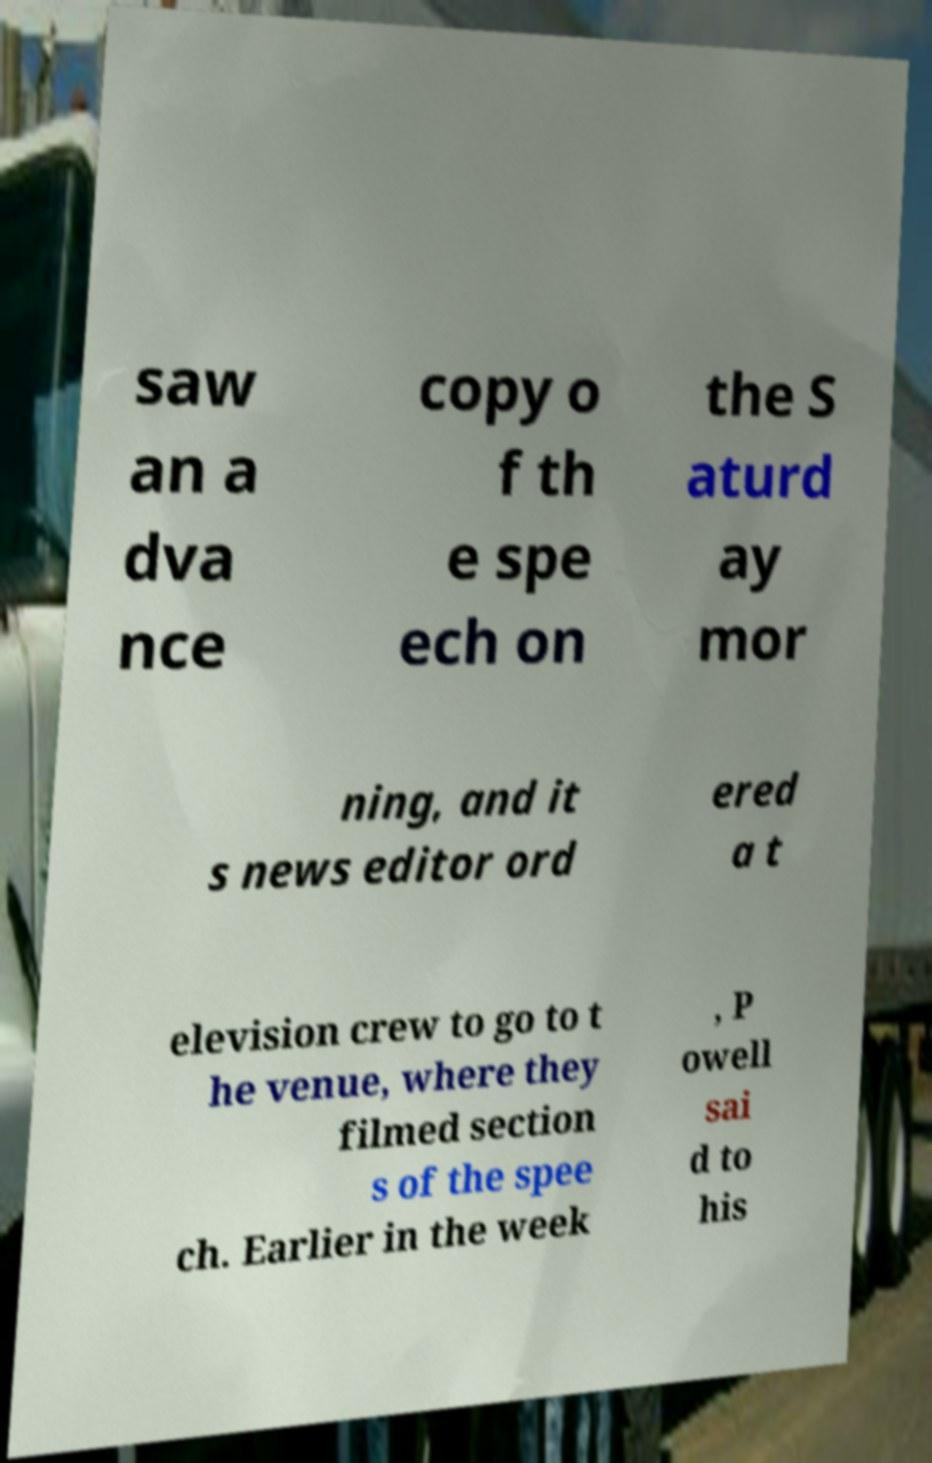Please read and relay the text visible in this image. What does it say? saw an a dva nce copy o f th e spe ech on the S aturd ay mor ning, and it s news editor ord ered a t elevision crew to go to t he venue, where they filmed section s of the spee ch. Earlier in the week , P owell sai d to his 